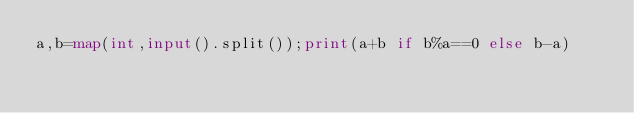<code> <loc_0><loc_0><loc_500><loc_500><_Python_>a,b=map(int,input().split());print(a+b if b%a==0 else b-a)</code> 